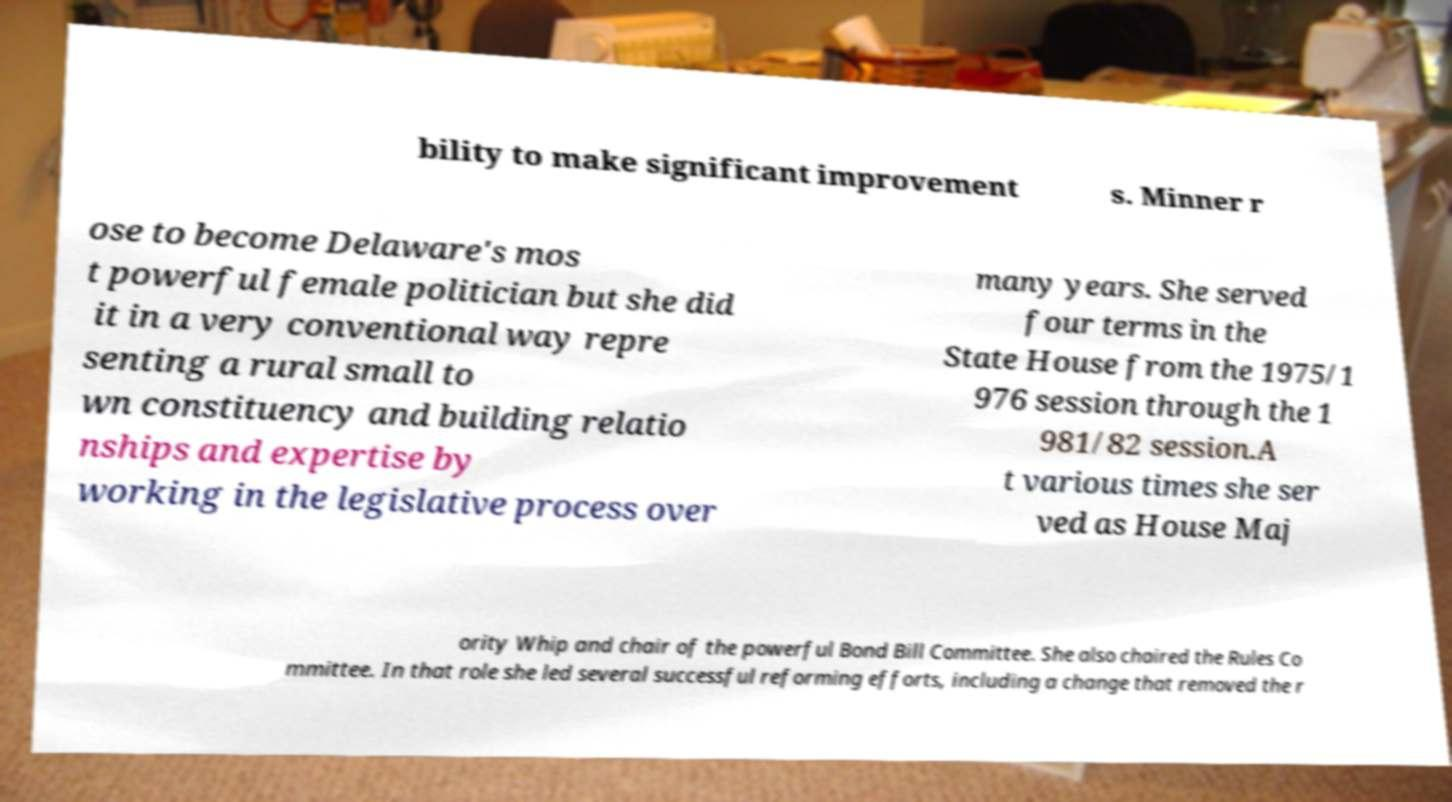Could you assist in decoding the text presented in this image and type it out clearly? bility to make significant improvement s. Minner r ose to become Delaware's mos t powerful female politician but she did it in a very conventional way repre senting a rural small to wn constituency and building relatio nships and expertise by working in the legislative process over many years. She served four terms in the State House from the 1975/1 976 session through the 1 981/82 session.A t various times she ser ved as House Maj ority Whip and chair of the powerful Bond Bill Committee. She also chaired the Rules Co mmittee. In that role she led several successful reforming efforts, including a change that removed the r 